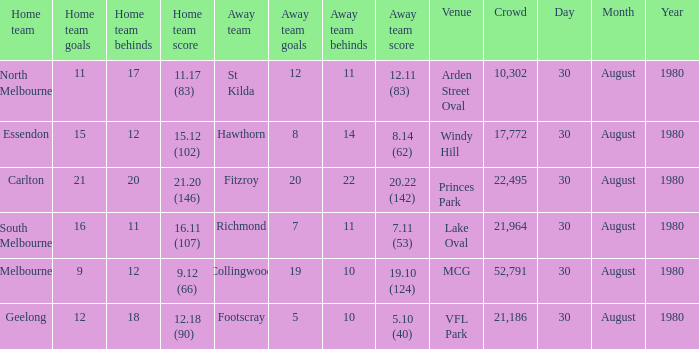What was the score for south melbourne at home? 16.11 (107). Parse the full table. {'header': ['Home team', 'Home team goals', 'Home team behinds', 'Home team score', 'Away team', 'Away team goals', 'Away team behinds', 'Away team score', 'Venue', 'Crowd', 'Day', 'Month', 'Year'], 'rows': [['North Melbourne', '11', '17', '11.17 (83)', 'St Kilda', '12', '11', '12.11 (83)', 'Arden Street Oval', '10,302', '30', 'August', '1980'], ['Essendon', '15', '12', '15.12 (102)', 'Hawthorn', '8', '14', '8.14 (62)', 'Windy Hill', '17,772', '30', 'August', '1980'], ['Carlton', '21', '20', '21.20 (146)', 'Fitzroy', '20', '22', '20.22 (142)', 'Princes Park', '22,495', '30', 'August', '1980'], ['South Melbourne', '16', '11', '16.11 (107)', 'Richmond', '7', '11', '7.11 (53)', 'Lake Oval', '21,964', '30', 'August', '1980'], ['Melbourne', '9', '12', '9.12 (66)', 'Collingwood', '19', '10', '19.10 (124)', 'MCG', '52,791', '30', 'August', '1980'], ['Geelong', '12', '18', '12.18 (90)', 'Footscray', '5', '10', '5.10 (40)', 'VFL Park', '21,186', '30', 'August', '1980']]} 